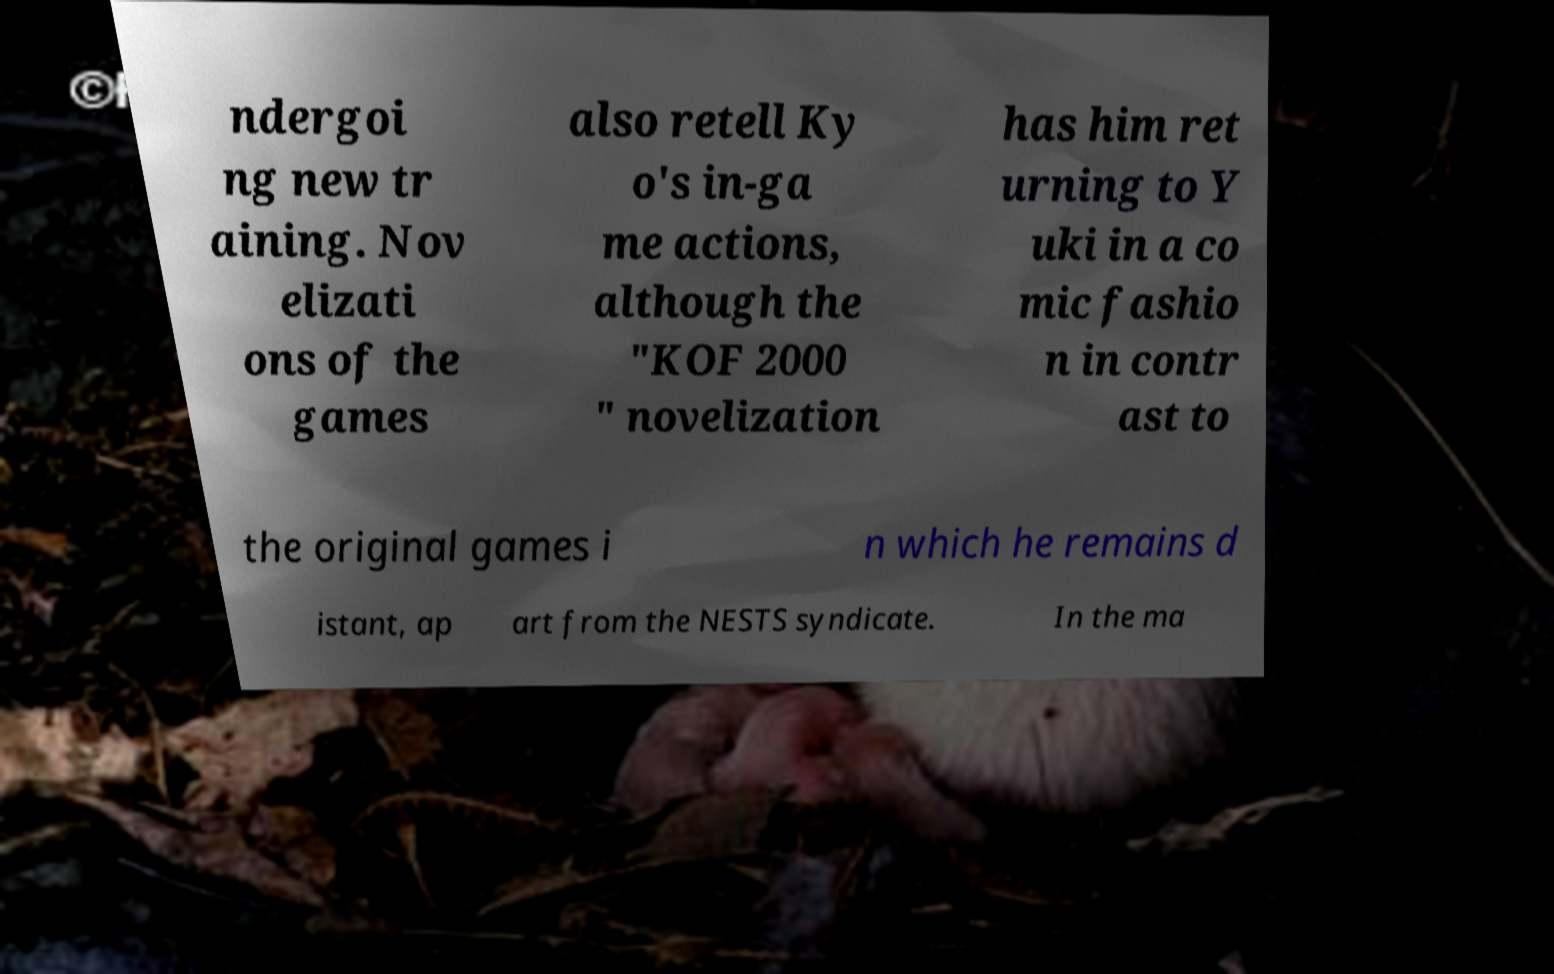Could you assist in decoding the text presented in this image and type it out clearly? ndergoi ng new tr aining. Nov elizati ons of the games also retell Ky o's in-ga me actions, although the "KOF 2000 " novelization has him ret urning to Y uki in a co mic fashio n in contr ast to the original games i n which he remains d istant, ap art from the NESTS syndicate. In the ma 